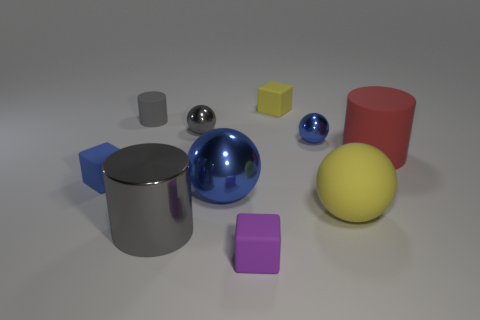Imagine these objects are part of a child's game, what might be the rules? In this imaginary child's game, each object might represent a different point value based on its shape and color. For example, spheres could be 1 point, cubes 2 points, and cylinders 3 points. Every time a player successfully stacks an object on another without tipping any over, they earn the designated points. The larger objects are stable bases, and the smaller objects are more challenging to stack. The goal could be to accumulate the most points or build the highest structure within a time limit. The use of color could add another layer to the game, such as bonus points for stacking objects of the same color or creating specific color patterns. 